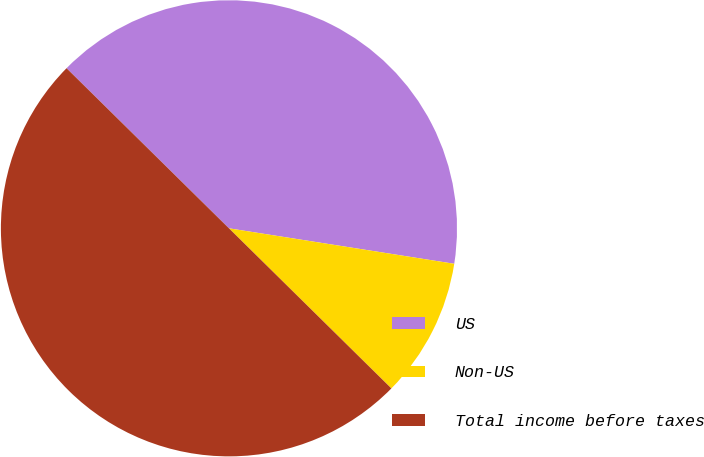Convert chart. <chart><loc_0><loc_0><loc_500><loc_500><pie_chart><fcel>US<fcel>Non-US<fcel>Total income before taxes<nl><fcel>40.1%<fcel>9.9%<fcel>50.0%<nl></chart> 